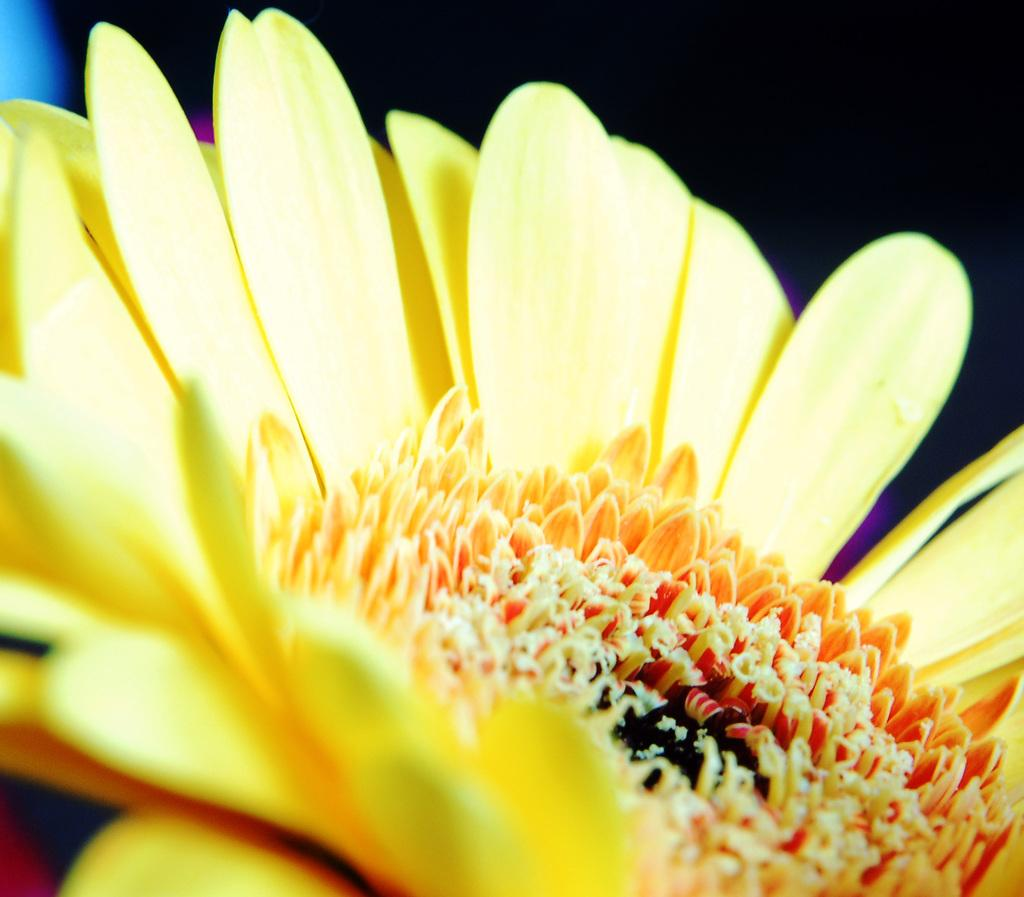What type of flower is present in the image? There is a yellow flower in the image. What scientific apparatus can be seen solving a riddle in the image? There is no scientific apparatus or riddle present in the image; it features a yellow flower. 